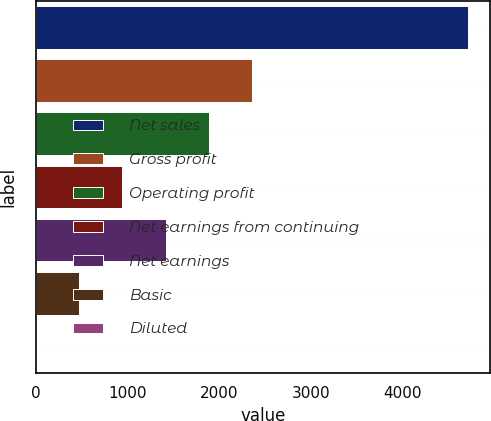<chart> <loc_0><loc_0><loc_500><loc_500><bar_chart><fcel>Net sales<fcel>Gross profit<fcel>Operating profit<fcel>Net earnings from continuing<fcel>Net earnings<fcel>Basic<fcel>Diluted<nl><fcel>4716.6<fcel>2358.7<fcel>1887.12<fcel>943.96<fcel>1415.54<fcel>472.38<fcel>0.8<nl></chart> 